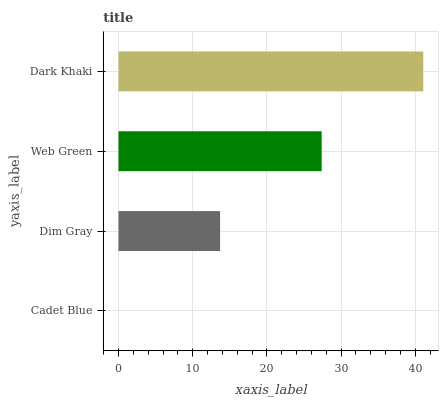Is Cadet Blue the minimum?
Answer yes or no. Yes. Is Dark Khaki the maximum?
Answer yes or no. Yes. Is Dim Gray the minimum?
Answer yes or no. No. Is Dim Gray the maximum?
Answer yes or no. No. Is Dim Gray greater than Cadet Blue?
Answer yes or no. Yes. Is Cadet Blue less than Dim Gray?
Answer yes or no. Yes. Is Cadet Blue greater than Dim Gray?
Answer yes or no. No. Is Dim Gray less than Cadet Blue?
Answer yes or no. No. Is Web Green the high median?
Answer yes or no. Yes. Is Dim Gray the low median?
Answer yes or no. Yes. Is Cadet Blue the high median?
Answer yes or no. No. Is Web Green the low median?
Answer yes or no. No. 